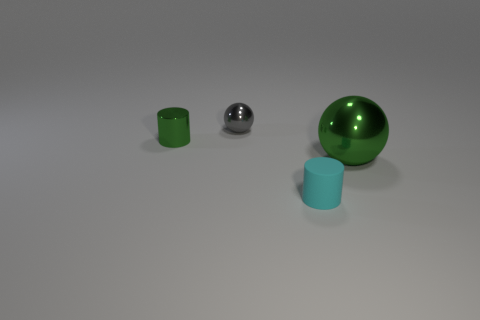How many big green things are made of the same material as the small gray ball?
Ensure brevity in your answer.  1. There is a metallic object that is the same color as the big sphere; what is its shape?
Provide a short and direct response. Cylinder. There is a green object that is to the right of the cyan rubber cylinder; is it the same shape as the tiny cyan object?
Offer a terse response. No. The sphere that is the same material as the large green object is what color?
Give a very brief answer. Gray. Are there any green cylinders that are to the right of the green shiny object on the left side of the shiny object that is in front of the tiny green shiny thing?
Provide a short and direct response. No. What shape is the gray metallic object?
Keep it short and to the point. Sphere. Are there fewer objects in front of the small shiny sphere than cyan blocks?
Your answer should be compact. No. Is there a small matte thing that has the same shape as the gray metal thing?
Provide a succinct answer. No. There is a gray object that is the same size as the green cylinder; what is its shape?
Your response must be concise. Sphere. How many things are either big yellow metal cylinders or metallic balls?
Ensure brevity in your answer.  2. 